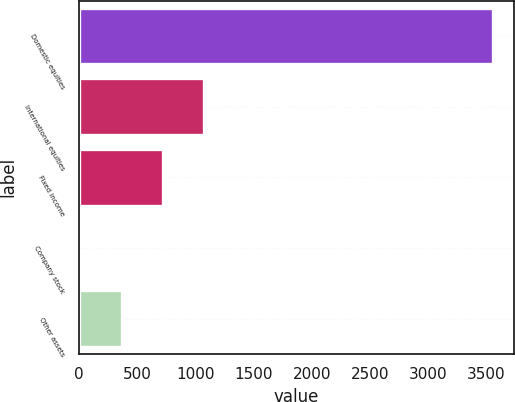Convert chart. <chart><loc_0><loc_0><loc_500><loc_500><bar_chart><fcel>Domestic equities<fcel>International equities<fcel>Fixed income<fcel>Company stock<fcel>Other assets<nl><fcel>3555<fcel>1077<fcel>723<fcel>15<fcel>369<nl></chart> 